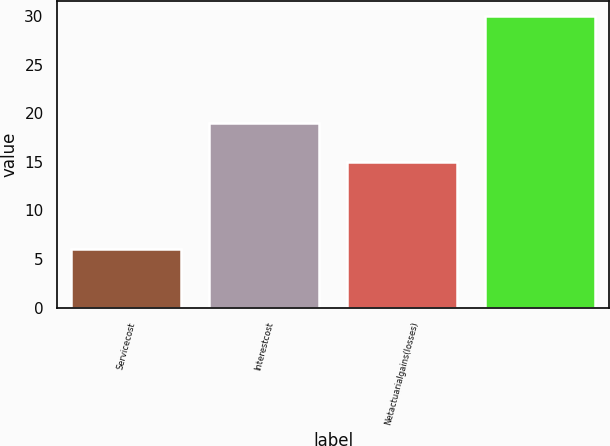Convert chart. <chart><loc_0><loc_0><loc_500><loc_500><bar_chart><fcel>Servicecost<fcel>Interestcost<fcel>Netactuarialgains(losses)<fcel>Unnamed: 3<nl><fcel>6<fcel>19<fcel>15<fcel>30<nl></chart> 